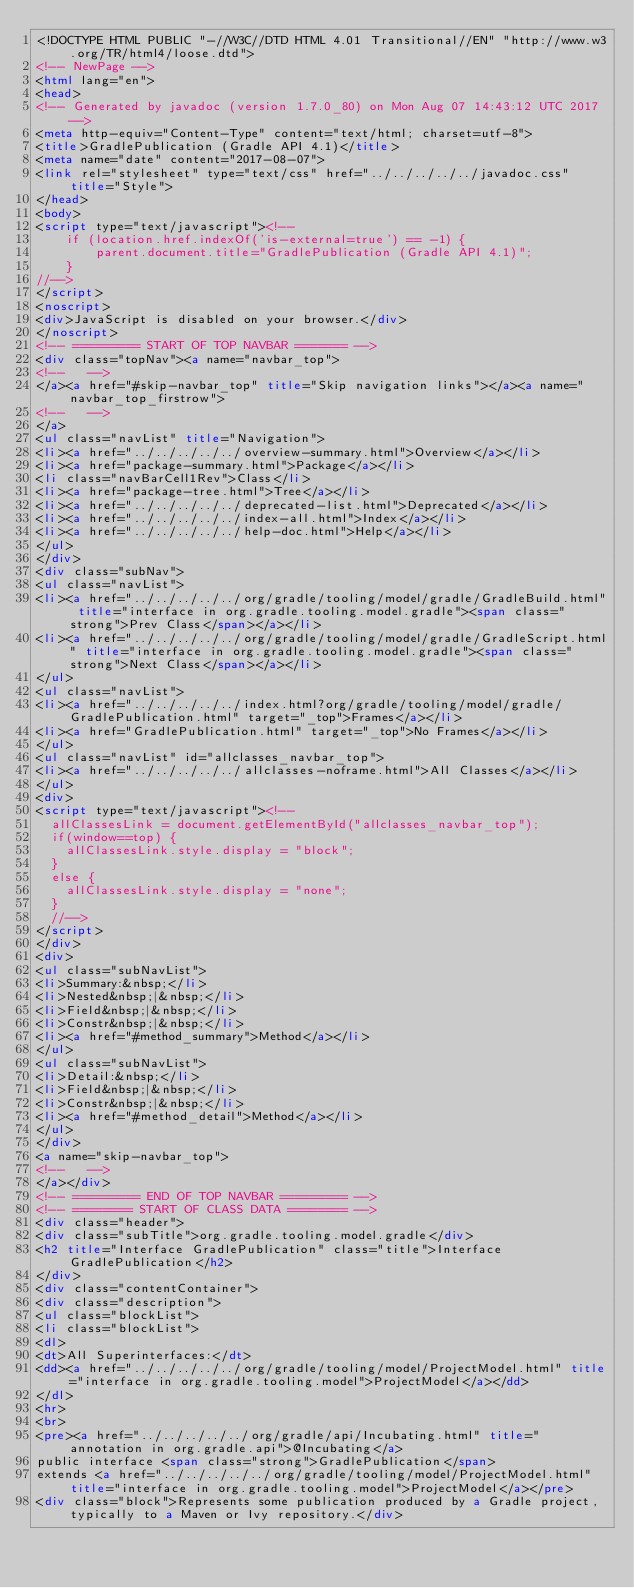Convert code to text. <code><loc_0><loc_0><loc_500><loc_500><_HTML_><!DOCTYPE HTML PUBLIC "-//W3C//DTD HTML 4.01 Transitional//EN" "http://www.w3.org/TR/html4/loose.dtd">
<!-- NewPage -->
<html lang="en">
<head>
<!-- Generated by javadoc (version 1.7.0_80) on Mon Aug 07 14:43:12 UTC 2017 -->
<meta http-equiv="Content-Type" content="text/html; charset=utf-8">
<title>GradlePublication (Gradle API 4.1)</title>
<meta name="date" content="2017-08-07">
<link rel="stylesheet" type="text/css" href="../../../../../javadoc.css" title="Style">
</head>
<body>
<script type="text/javascript"><!--
    if (location.href.indexOf('is-external=true') == -1) {
        parent.document.title="GradlePublication (Gradle API 4.1)";
    }
//-->
</script>
<noscript>
<div>JavaScript is disabled on your browser.</div>
</noscript>
<!-- ========= START OF TOP NAVBAR ======= -->
<div class="topNav"><a name="navbar_top">
<!--   -->
</a><a href="#skip-navbar_top" title="Skip navigation links"></a><a name="navbar_top_firstrow">
<!--   -->
</a>
<ul class="navList" title="Navigation">
<li><a href="../../../../../overview-summary.html">Overview</a></li>
<li><a href="package-summary.html">Package</a></li>
<li class="navBarCell1Rev">Class</li>
<li><a href="package-tree.html">Tree</a></li>
<li><a href="../../../../../deprecated-list.html">Deprecated</a></li>
<li><a href="../../../../../index-all.html">Index</a></li>
<li><a href="../../../../../help-doc.html">Help</a></li>
</ul>
</div>
<div class="subNav">
<ul class="navList">
<li><a href="../../../../../org/gradle/tooling/model/gradle/GradleBuild.html" title="interface in org.gradle.tooling.model.gradle"><span class="strong">Prev Class</span></a></li>
<li><a href="../../../../../org/gradle/tooling/model/gradle/GradleScript.html" title="interface in org.gradle.tooling.model.gradle"><span class="strong">Next Class</span></a></li>
</ul>
<ul class="navList">
<li><a href="../../../../../index.html?org/gradle/tooling/model/gradle/GradlePublication.html" target="_top">Frames</a></li>
<li><a href="GradlePublication.html" target="_top">No Frames</a></li>
</ul>
<ul class="navList" id="allclasses_navbar_top">
<li><a href="../../../../../allclasses-noframe.html">All Classes</a></li>
</ul>
<div>
<script type="text/javascript"><!--
  allClassesLink = document.getElementById("allclasses_navbar_top");
  if(window==top) {
    allClassesLink.style.display = "block";
  }
  else {
    allClassesLink.style.display = "none";
  }
  //-->
</script>
</div>
<div>
<ul class="subNavList">
<li>Summary:&nbsp;</li>
<li>Nested&nbsp;|&nbsp;</li>
<li>Field&nbsp;|&nbsp;</li>
<li>Constr&nbsp;|&nbsp;</li>
<li><a href="#method_summary">Method</a></li>
</ul>
<ul class="subNavList">
<li>Detail:&nbsp;</li>
<li>Field&nbsp;|&nbsp;</li>
<li>Constr&nbsp;|&nbsp;</li>
<li><a href="#method_detail">Method</a></li>
</ul>
</div>
<a name="skip-navbar_top">
<!--   -->
</a></div>
<!-- ========= END OF TOP NAVBAR ========= -->
<!-- ======== START OF CLASS DATA ======== -->
<div class="header">
<div class="subTitle">org.gradle.tooling.model.gradle</div>
<h2 title="Interface GradlePublication" class="title">Interface GradlePublication</h2>
</div>
<div class="contentContainer">
<div class="description">
<ul class="blockList">
<li class="blockList">
<dl>
<dt>All Superinterfaces:</dt>
<dd><a href="../../../../../org/gradle/tooling/model/ProjectModel.html" title="interface in org.gradle.tooling.model">ProjectModel</a></dd>
</dl>
<hr>
<br>
<pre><a href="../../../../../org/gradle/api/Incubating.html" title="annotation in org.gradle.api">@Incubating</a>
public interface <span class="strong">GradlePublication</span>
extends <a href="../../../../../org/gradle/tooling/model/ProjectModel.html" title="interface in org.gradle.tooling.model">ProjectModel</a></pre>
<div class="block">Represents some publication produced by a Gradle project, typically to a Maven or Ivy repository.</div></code> 